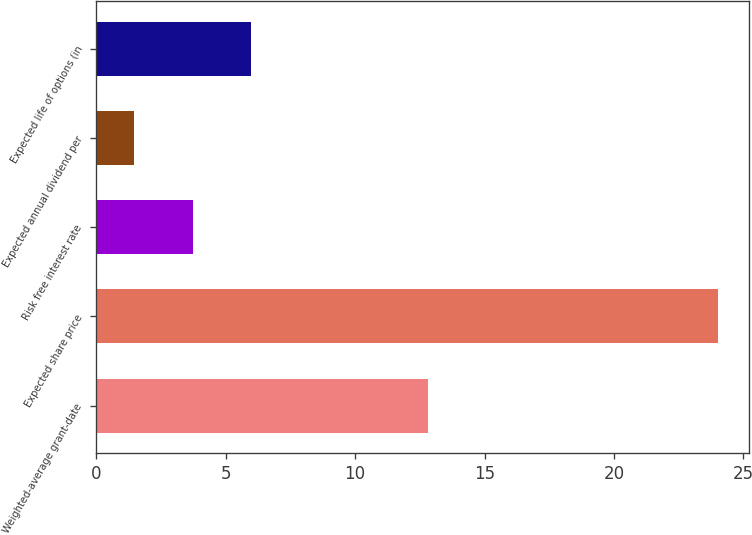Convert chart. <chart><loc_0><loc_0><loc_500><loc_500><bar_chart><fcel>Weighted-average grant-date<fcel>Expected share price<fcel>Risk free interest rate<fcel>Expected annual dividend per<fcel>Expected life of options (in<nl><fcel>12.8<fcel>24<fcel>3.73<fcel>1.48<fcel>5.98<nl></chart> 